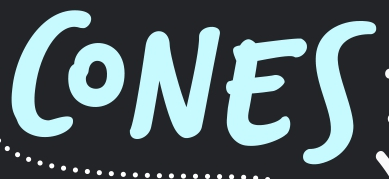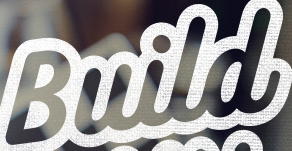Transcribe the words shown in these images in order, separated by a semicolon. CONES; Build 